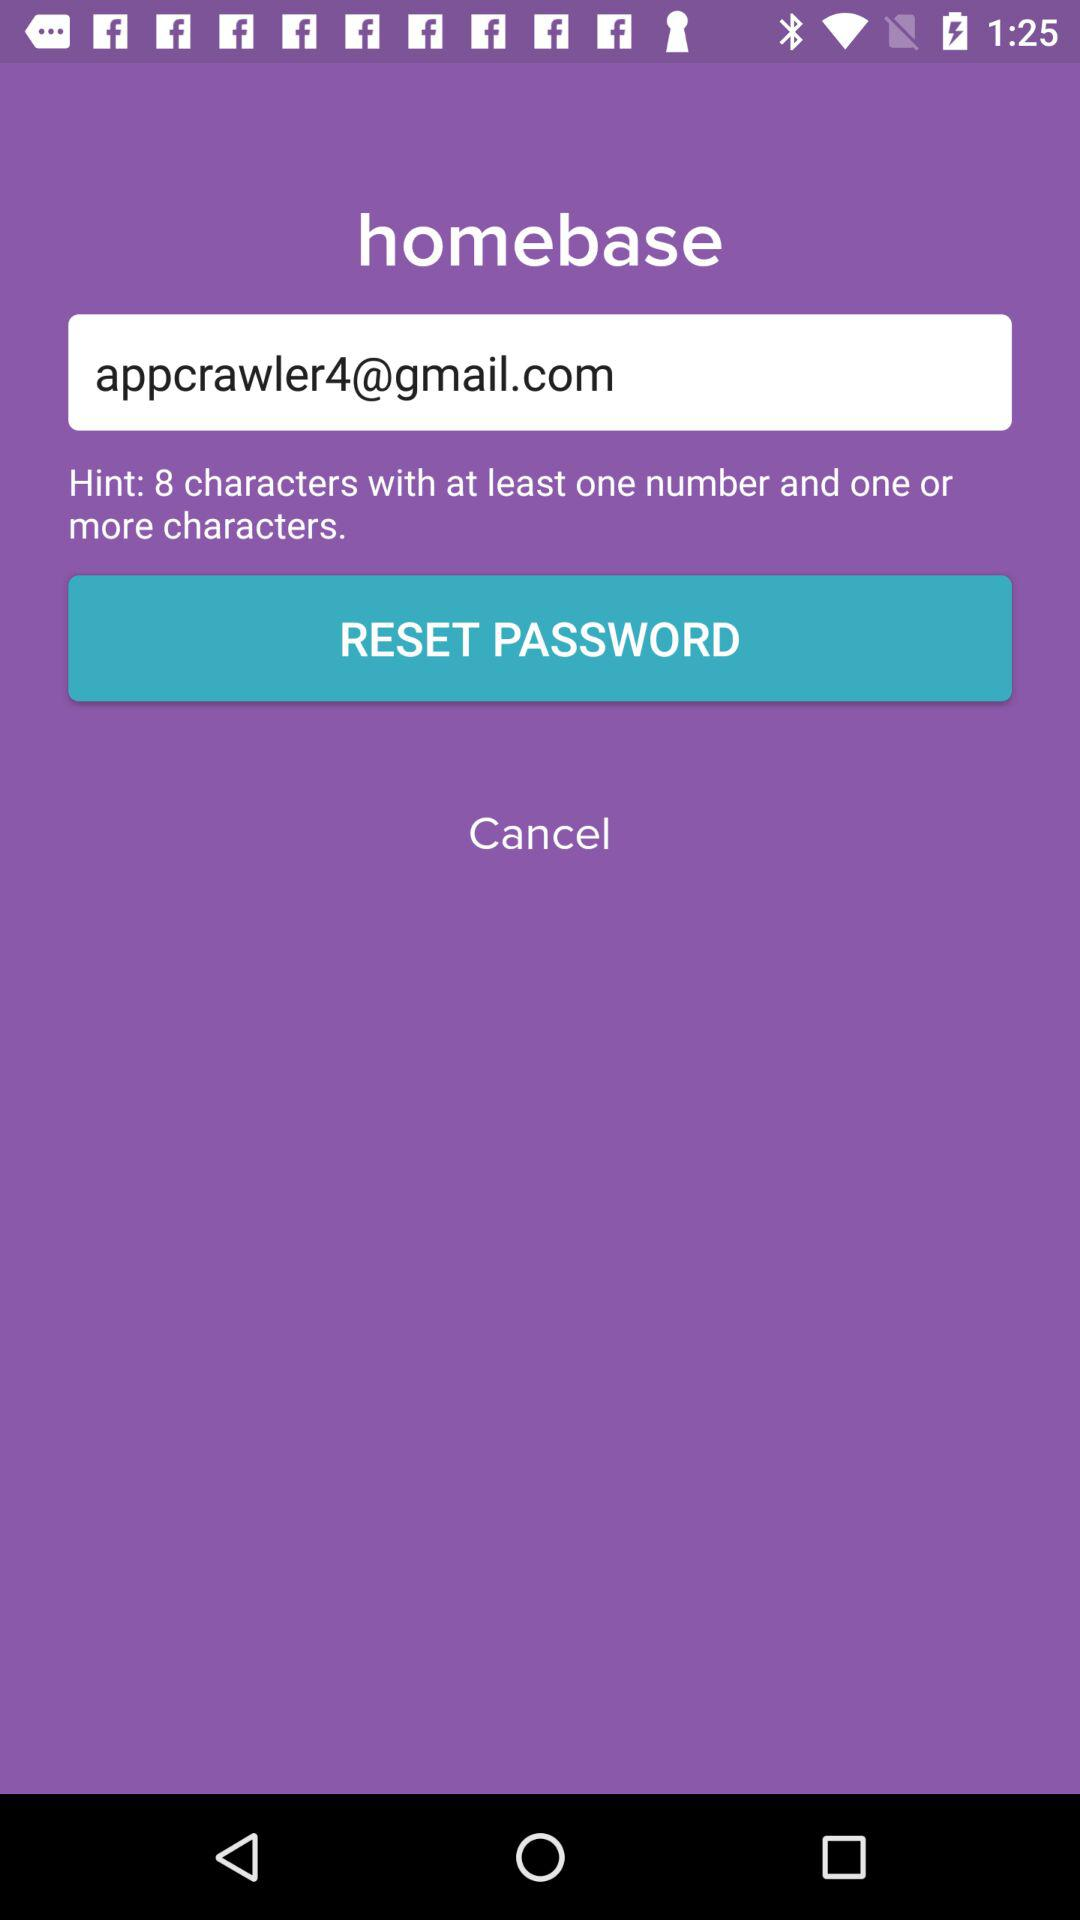What is the limit of characters?
When the provided information is insufficient, respond with <no answer>. <no answer> 